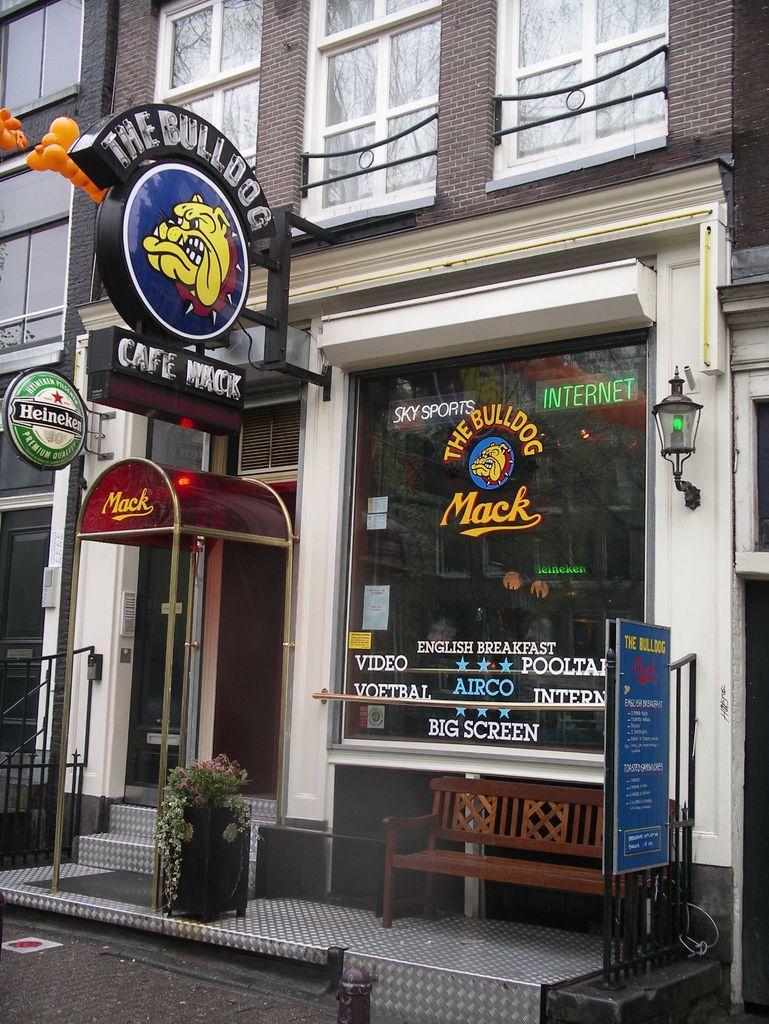How would you summarize this image in a sentence or two? in this image the building is there the outside the building something is there like chair,light and some posters and pot with tree and the back ground is very morning 